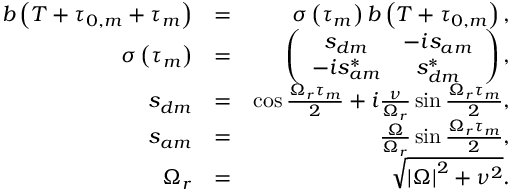Convert formula to latex. <formula><loc_0><loc_0><loc_500><loc_500>\begin{array} { r l r } { b \left ( T + \tau _ { 0 , m } + \tau _ { m } \right ) } & { = } & { \sigma \left ( \tau _ { m } \right ) b \left ( T + \tau _ { 0 , m } \right ) , } \\ { \sigma \left ( \tau _ { m } \right ) } & { = } & { \left ( \begin{array} { c c } { s _ { d m } } & { - i s _ { a m } } \\ { - i s _ { a m } ^ { \ast } } & { s _ { d m } ^ { \ast } } \end{array} \right ) , } \\ { s _ { d m } } & { = } & { \cos \frac { \Omega _ { r } \tau _ { m } } { 2 } + i \frac { \nu } { \Omega _ { r } } \sin \frac { \Omega _ { r } \tau _ { m } } { 2 } , } \\ { s _ { a m } } & { = } & { \frac { \Omega } { \Omega _ { r } } \sin \frac { \Omega _ { r } \tau _ { m } } { 2 } , } \\ { \Omega _ { r } } & { = } & { \sqrt { \left | \Omega \right | ^ { 2 } + \nu ^ { 2 } } . } \end{array}</formula> 